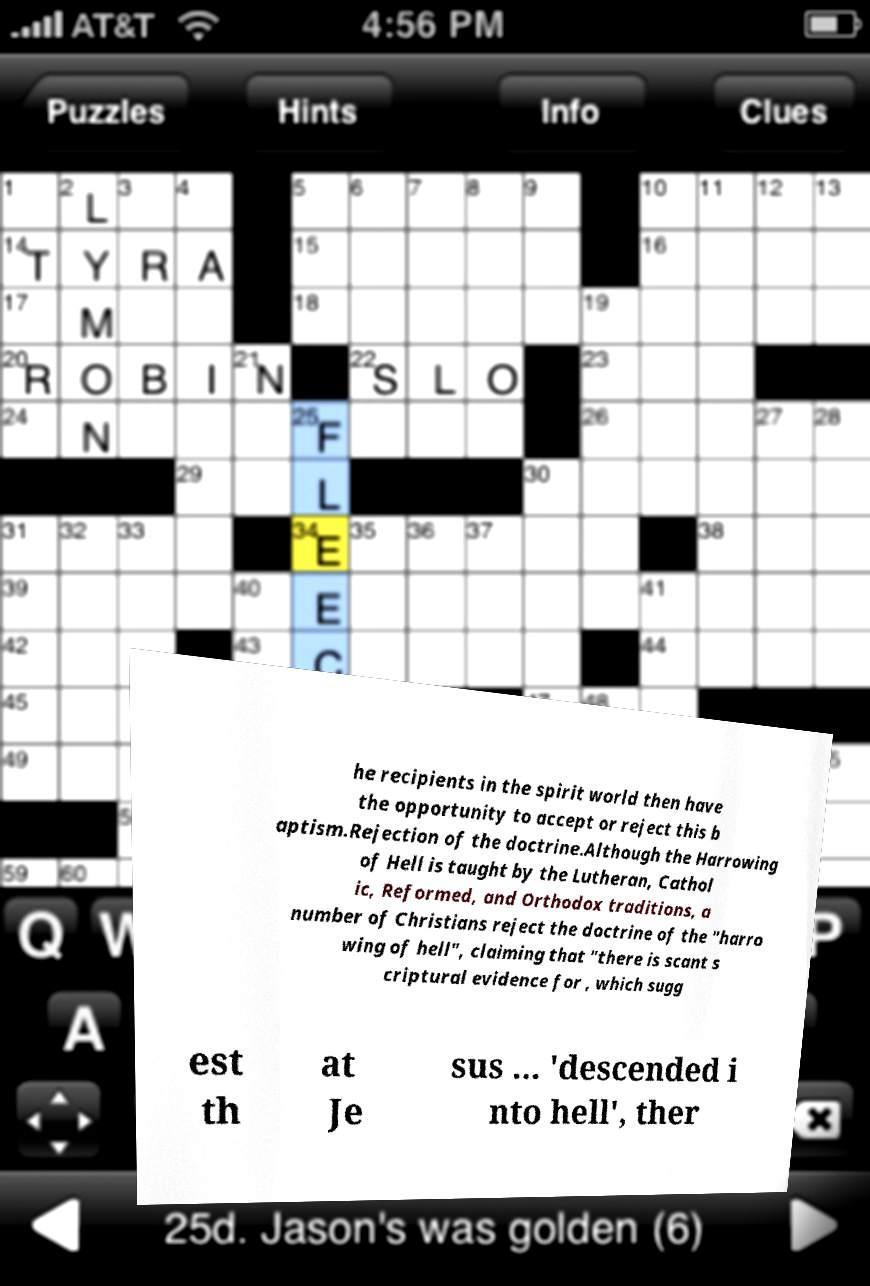There's text embedded in this image that I need extracted. Can you transcribe it verbatim? he recipients in the spirit world then have the opportunity to accept or reject this b aptism.Rejection of the doctrine.Although the Harrowing of Hell is taught by the Lutheran, Cathol ic, Reformed, and Orthodox traditions, a number of Christians reject the doctrine of the "harro wing of hell", claiming that "there is scant s criptural evidence for , which sugg est th at Je sus ... 'descended i nto hell', ther 